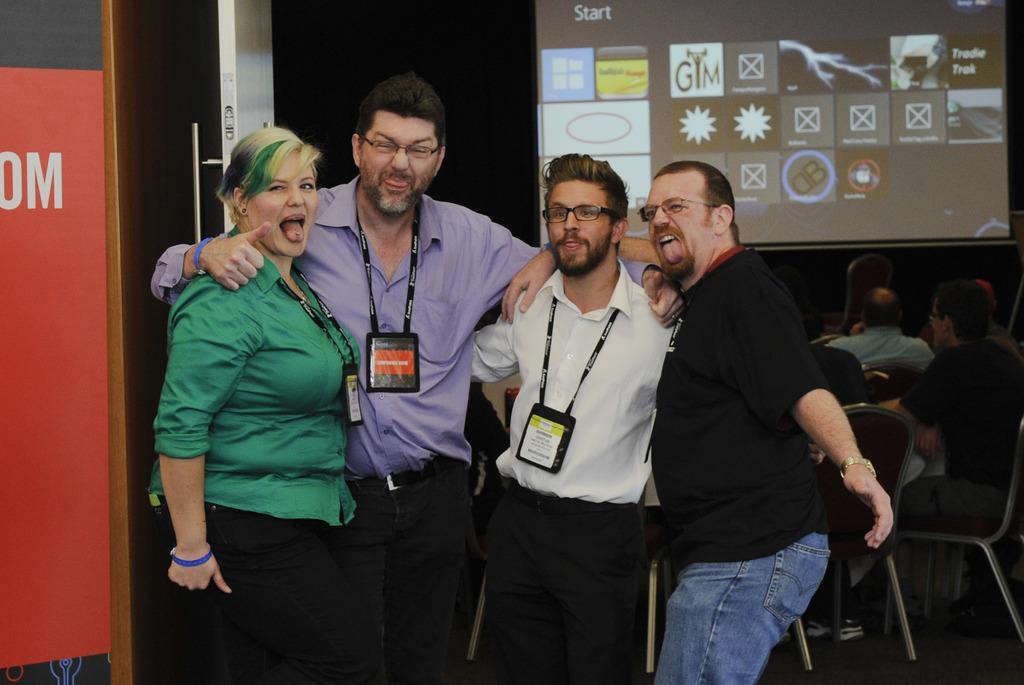How would you summarize this image in a sentence or two? In this picture we can observe four members standing. Three of them were men and one of them was a woman. All of them were having tags in their necks. In the background there is a white color door and a projector display screen. 